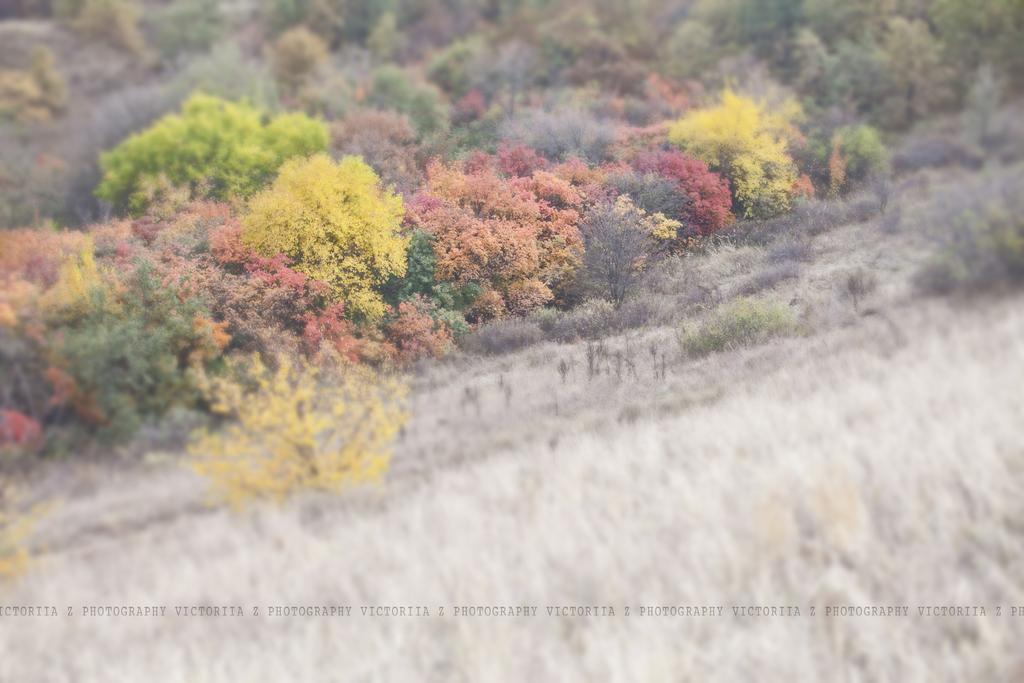What is the main subject of the image? The main subject of the image is many plants. Can you describe the plants in the image? The plants have different colors. What is the ground made of in the image? There is dry grass at the bottom of the image. How many bikes can be seen parked among the plants in the image? There are no bikes present in the image; it only features plants and dry grass. What type of precipitation is falling in the image? There is no precipitation visible in the image, so it cannot be determined if it is sleet or any other type. 